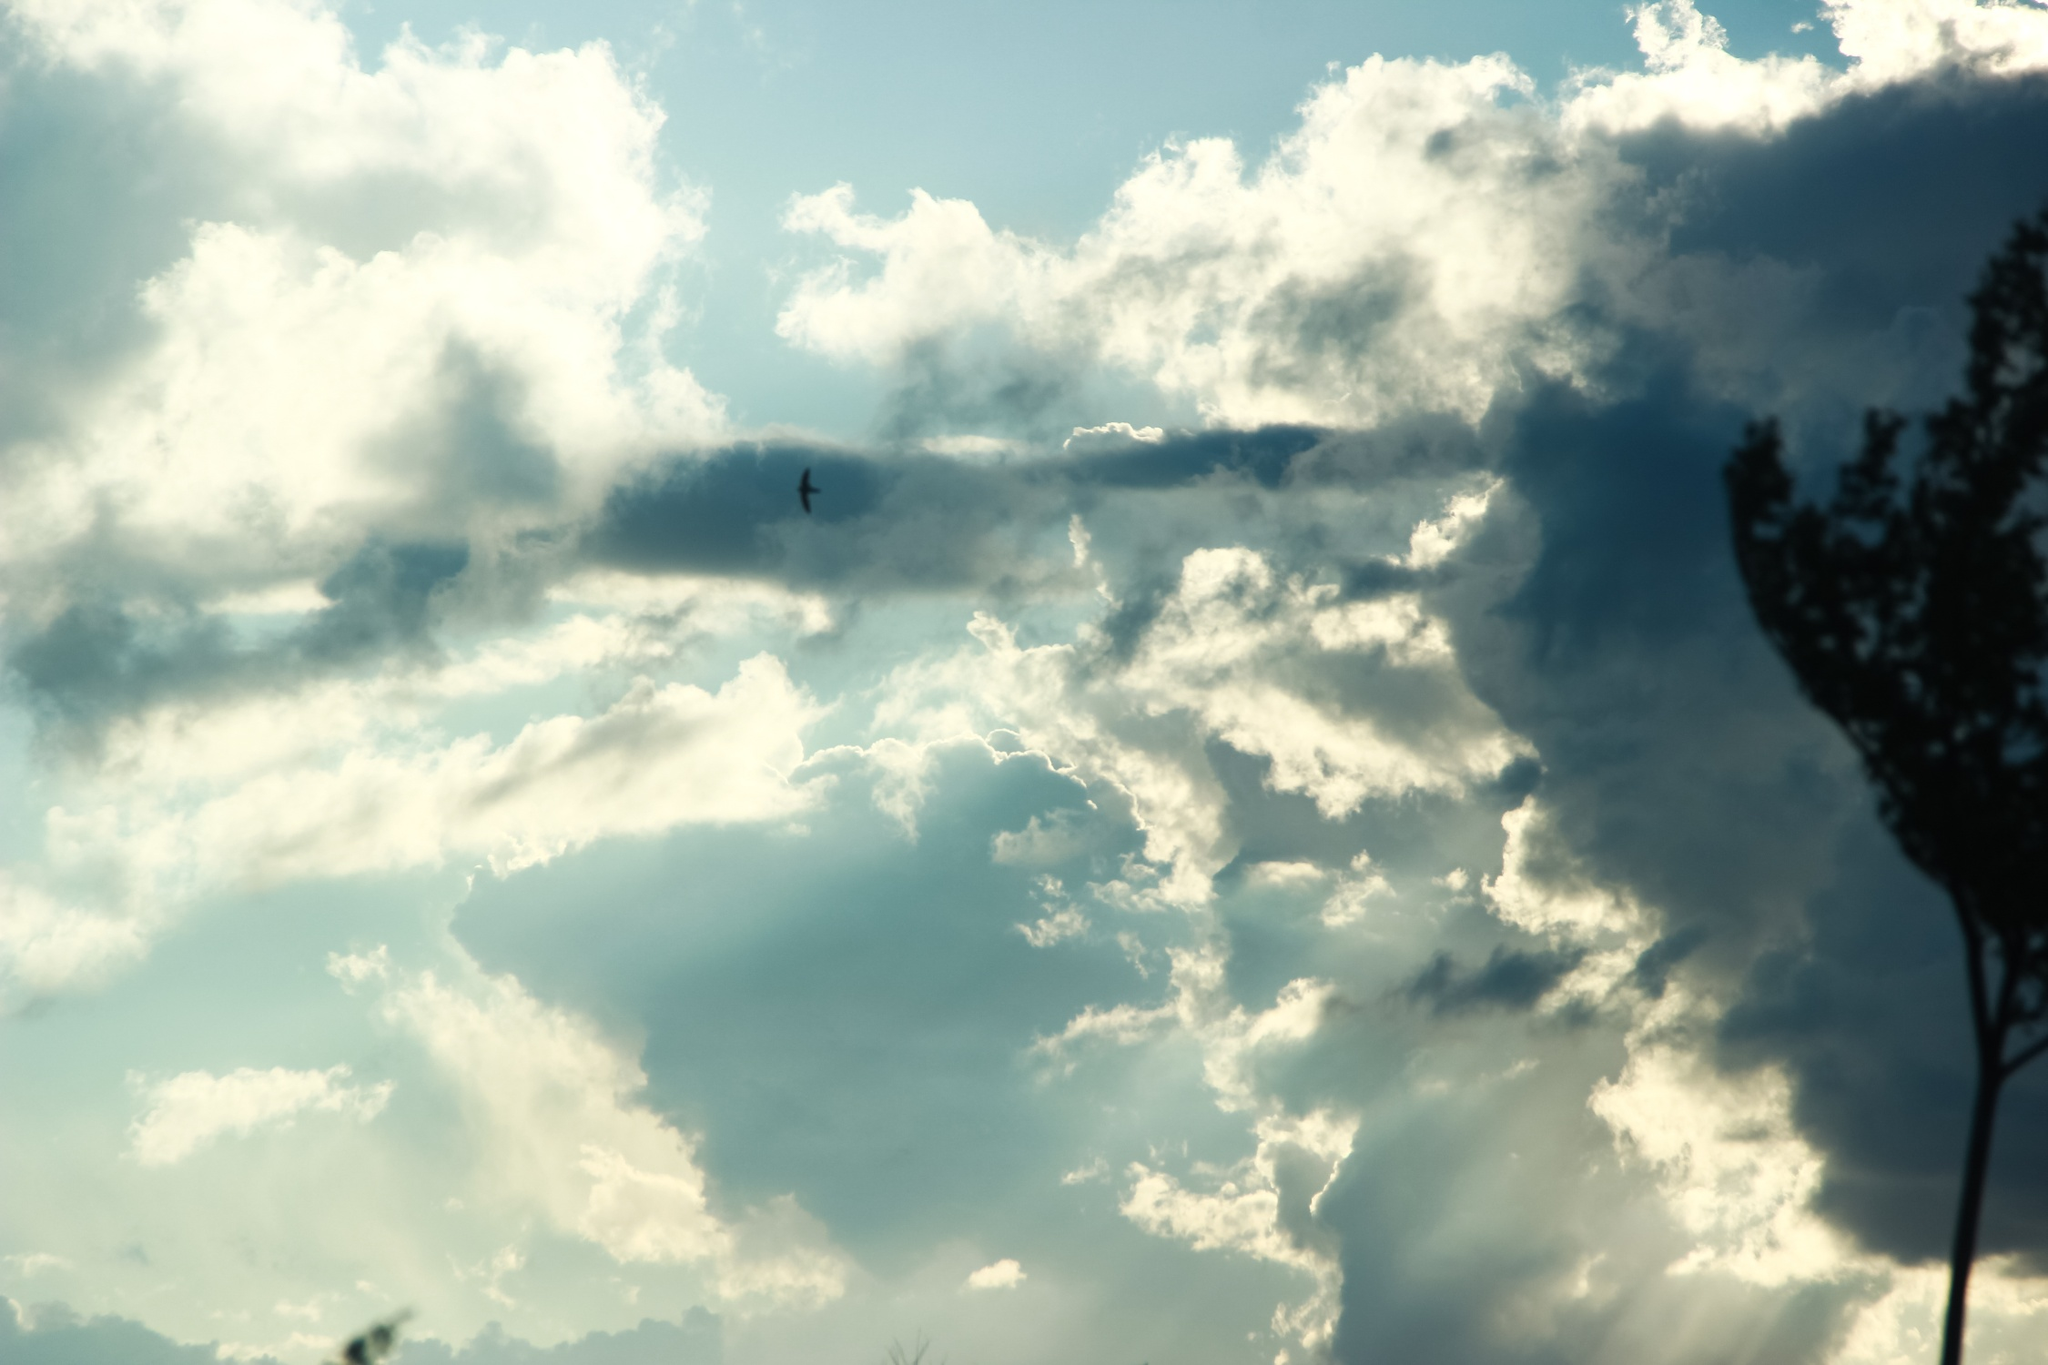From a scientific perspective, how do clouds form? Clouds form through the process of condensation in the atmosphere. When warm air rises, it cools down. As the air cools, the water vapor within it condenses into tiny water droplets or ice crystals. These droplets or crystals cluster together to form clouds. This usually happens on microscopic particles like dust, pollen, or sea salt, which act as nuclei for the water droplets. The type and appearance of the clouds that form depend on various factors, including the altitude, the atmospheric conditions, and the amount of water vapor present. 